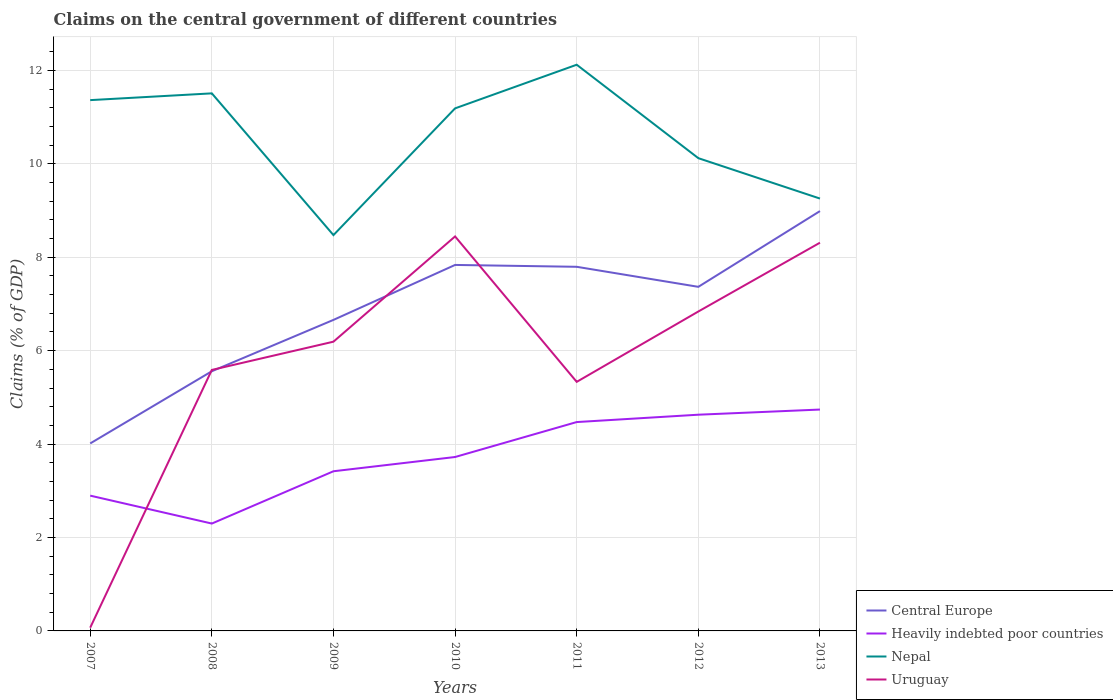Across all years, what is the maximum percentage of GDP claimed on the central government in Uruguay?
Give a very brief answer. 0.07. In which year was the percentage of GDP claimed on the central government in Uruguay maximum?
Offer a very short reply. 2007. What is the total percentage of GDP claimed on the central government in Heavily indebted poor countries in the graph?
Provide a succinct answer. -0.11. What is the difference between the highest and the second highest percentage of GDP claimed on the central government in Heavily indebted poor countries?
Your response must be concise. 2.44. What is the difference between the highest and the lowest percentage of GDP claimed on the central government in Uruguay?
Give a very brief answer. 4. How many years are there in the graph?
Ensure brevity in your answer.  7. Does the graph contain grids?
Keep it short and to the point. Yes. Where does the legend appear in the graph?
Keep it short and to the point. Bottom right. How many legend labels are there?
Keep it short and to the point. 4. What is the title of the graph?
Your response must be concise. Claims on the central government of different countries. What is the label or title of the Y-axis?
Provide a succinct answer. Claims (% of GDP). What is the Claims (% of GDP) of Central Europe in 2007?
Your answer should be very brief. 4.01. What is the Claims (% of GDP) in Heavily indebted poor countries in 2007?
Offer a terse response. 2.9. What is the Claims (% of GDP) of Nepal in 2007?
Your answer should be compact. 11.36. What is the Claims (% of GDP) of Uruguay in 2007?
Provide a succinct answer. 0.07. What is the Claims (% of GDP) of Central Europe in 2008?
Make the answer very short. 5.56. What is the Claims (% of GDP) of Heavily indebted poor countries in 2008?
Provide a succinct answer. 2.3. What is the Claims (% of GDP) of Nepal in 2008?
Ensure brevity in your answer.  11.51. What is the Claims (% of GDP) of Uruguay in 2008?
Keep it short and to the point. 5.59. What is the Claims (% of GDP) in Central Europe in 2009?
Your response must be concise. 6.66. What is the Claims (% of GDP) in Heavily indebted poor countries in 2009?
Keep it short and to the point. 3.42. What is the Claims (% of GDP) of Nepal in 2009?
Your answer should be very brief. 8.47. What is the Claims (% of GDP) of Uruguay in 2009?
Give a very brief answer. 6.19. What is the Claims (% of GDP) in Central Europe in 2010?
Your answer should be very brief. 7.84. What is the Claims (% of GDP) of Heavily indebted poor countries in 2010?
Offer a terse response. 3.72. What is the Claims (% of GDP) of Nepal in 2010?
Your answer should be compact. 11.19. What is the Claims (% of GDP) in Uruguay in 2010?
Make the answer very short. 8.45. What is the Claims (% of GDP) in Central Europe in 2011?
Give a very brief answer. 7.8. What is the Claims (% of GDP) of Heavily indebted poor countries in 2011?
Your response must be concise. 4.47. What is the Claims (% of GDP) of Nepal in 2011?
Provide a short and direct response. 12.12. What is the Claims (% of GDP) in Uruguay in 2011?
Offer a terse response. 5.33. What is the Claims (% of GDP) in Central Europe in 2012?
Your answer should be compact. 7.37. What is the Claims (% of GDP) of Heavily indebted poor countries in 2012?
Make the answer very short. 4.63. What is the Claims (% of GDP) of Nepal in 2012?
Provide a short and direct response. 10.12. What is the Claims (% of GDP) of Uruguay in 2012?
Your response must be concise. 6.84. What is the Claims (% of GDP) in Central Europe in 2013?
Offer a terse response. 8.99. What is the Claims (% of GDP) of Heavily indebted poor countries in 2013?
Your response must be concise. 4.74. What is the Claims (% of GDP) in Nepal in 2013?
Your answer should be compact. 9.26. What is the Claims (% of GDP) in Uruguay in 2013?
Make the answer very short. 8.31. Across all years, what is the maximum Claims (% of GDP) of Central Europe?
Ensure brevity in your answer.  8.99. Across all years, what is the maximum Claims (% of GDP) in Heavily indebted poor countries?
Offer a terse response. 4.74. Across all years, what is the maximum Claims (% of GDP) in Nepal?
Your answer should be very brief. 12.12. Across all years, what is the maximum Claims (% of GDP) of Uruguay?
Your answer should be very brief. 8.45. Across all years, what is the minimum Claims (% of GDP) of Central Europe?
Provide a succinct answer. 4.01. Across all years, what is the minimum Claims (% of GDP) of Heavily indebted poor countries?
Offer a very short reply. 2.3. Across all years, what is the minimum Claims (% of GDP) of Nepal?
Your answer should be compact. 8.47. Across all years, what is the minimum Claims (% of GDP) in Uruguay?
Your answer should be compact. 0.07. What is the total Claims (% of GDP) of Central Europe in the graph?
Your answer should be compact. 48.22. What is the total Claims (% of GDP) of Heavily indebted poor countries in the graph?
Make the answer very short. 26.18. What is the total Claims (% of GDP) of Nepal in the graph?
Make the answer very short. 74.04. What is the total Claims (% of GDP) of Uruguay in the graph?
Provide a succinct answer. 40.78. What is the difference between the Claims (% of GDP) of Central Europe in 2007 and that in 2008?
Keep it short and to the point. -1.55. What is the difference between the Claims (% of GDP) of Heavily indebted poor countries in 2007 and that in 2008?
Your response must be concise. 0.6. What is the difference between the Claims (% of GDP) in Nepal in 2007 and that in 2008?
Offer a very short reply. -0.14. What is the difference between the Claims (% of GDP) in Uruguay in 2007 and that in 2008?
Provide a short and direct response. -5.52. What is the difference between the Claims (% of GDP) of Central Europe in 2007 and that in 2009?
Provide a short and direct response. -2.65. What is the difference between the Claims (% of GDP) in Heavily indebted poor countries in 2007 and that in 2009?
Make the answer very short. -0.52. What is the difference between the Claims (% of GDP) in Nepal in 2007 and that in 2009?
Provide a succinct answer. 2.89. What is the difference between the Claims (% of GDP) of Uruguay in 2007 and that in 2009?
Offer a very short reply. -6.12. What is the difference between the Claims (% of GDP) in Central Europe in 2007 and that in 2010?
Offer a terse response. -3.82. What is the difference between the Claims (% of GDP) in Heavily indebted poor countries in 2007 and that in 2010?
Offer a very short reply. -0.83. What is the difference between the Claims (% of GDP) in Nepal in 2007 and that in 2010?
Provide a succinct answer. 0.18. What is the difference between the Claims (% of GDP) in Uruguay in 2007 and that in 2010?
Your response must be concise. -8.38. What is the difference between the Claims (% of GDP) of Central Europe in 2007 and that in 2011?
Make the answer very short. -3.78. What is the difference between the Claims (% of GDP) in Heavily indebted poor countries in 2007 and that in 2011?
Make the answer very short. -1.58. What is the difference between the Claims (% of GDP) in Nepal in 2007 and that in 2011?
Ensure brevity in your answer.  -0.76. What is the difference between the Claims (% of GDP) in Uruguay in 2007 and that in 2011?
Ensure brevity in your answer.  -5.26. What is the difference between the Claims (% of GDP) of Central Europe in 2007 and that in 2012?
Offer a very short reply. -3.35. What is the difference between the Claims (% of GDP) of Heavily indebted poor countries in 2007 and that in 2012?
Provide a short and direct response. -1.73. What is the difference between the Claims (% of GDP) of Nepal in 2007 and that in 2012?
Offer a very short reply. 1.24. What is the difference between the Claims (% of GDP) in Uruguay in 2007 and that in 2012?
Make the answer very short. -6.77. What is the difference between the Claims (% of GDP) in Central Europe in 2007 and that in 2013?
Keep it short and to the point. -4.97. What is the difference between the Claims (% of GDP) of Heavily indebted poor countries in 2007 and that in 2013?
Ensure brevity in your answer.  -1.84. What is the difference between the Claims (% of GDP) in Nepal in 2007 and that in 2013?
Offer a terse response. 2.11. What is the difference between the Claims (% of GDP) of Uruguay in 2007 and that in 2013?
Your response must be concise. -8.24. What is the difference between the Claims (% of GDP) of Central Europe in 2008 and that in 2009?
Offer a very short reply. -1.1. What is the difference between the Claims (% of GDP) in Heavily indebted poor countries in 2008 and that in 2009?
Give a very brief answer. -1.12. What is the difference between the Claims (% of GDP) in Nepal in 2008 and that in 2009?
Your response must be concise. 3.03. What is the difference between the Claims (% of GDP) in Uruguay in 2008 and that in 2009?
Offer a terse response. -0.6. What is the difference between the Claims (% of GDP) in Central Europe in 2008 and that in 2010?
Provide a short and direct response. -2.28. What is the difference between the Claims (% of GDP) in Heavily indebted poor countries in 2008 and that in 2010?
Your answer should be very brief. -1.42. What is the difference between the Claims (% of GDP) of Nepal in 2008 and that in 2010?
Keep it short and to the point. 0.32. What is the difference between the Claims (% of GDP) in Uruguay in 2008 and that in 2010?
Keep it short and to the point. -2.86. What is the difference between the Claims (% of GDP) of Central Europe in 2008 and that in 2011?
Keep it short and to the point. -2.24. What is the difference between the Claims (% of GDP) in Heavily indebted poor countries in 2008 and that in 2011?
Your response must be concise. -2.17. What is the difference between the Claims (% of GDP) in Nepal in 2008 and that in 2011?
Your answer should be very brief. -0.61. What is the difference between the Claims (% of GDP) in Uruguay in 2008 and that in 2011?
Your answer should be very brief. 0.26. What is the difference between the Claims (% of GDP) in Central Europe in 2008 and that in 2012?
Offer a terse response. -1.81. What is the difference between the Claims (% of GDP) of Heavily indebted poor countries in 2008 and that in 2012?
Ensure brevity in your answer.  -2.33. What is the difference between the Claims (% of GDP) of Nepal in 2008 and that in 2012?
Make the answer very short. 1.39. What is the difference between the Claims (% of GDP) in Uruguay in 2008 and that in 2012?
Your response must be concise. -1.25. What is the difference between the Claims (% of GDP) in Central Europe in 2008 and that in 2013?
Offer a very short reply. -3.43. What is the difference between the Claims (% of GDP) of Heavily indebted poor countries in 2008 and that in 2013?
Provide a short and direct response. -2.44. What is the difference between the Claims (% of GDP) of Nepal in 2008 and that in 2013?
Provide a short and direct response. 2.25. What is the difference between the Claims (% of GDP) of Uruguay in 2008 and that in 2013?
Make the answer very short. -2.72. What is the difference between the Claims (% of GDP) in Central Europe in 2009 and that in 2010?
Give a very brief answer. -1.18. What is the difference between the Claims (% of GDP) of Heavily indebted poor countries in 2009 and that in 2010?
Offer a terse response. -0.31. What is the difference between the Claims (% of GDP) in Nepal in 2009 and that in 2010?
Offer a very short reply. -2.71. What is the difference between the Claims (% of GDP) in Uruguay in 2009 and that in 2010?
Provide a short and direct response. -2.25. What is the difference between the Claims (% of GDP) of Central Europe in 2009 and that in 2011?
Your answer should be very brief. -1.14. What is the difference between the Claims (% of GDP) in Heavily indebted poor countries in 2009 and that in 2011?
Your response must be concise. -1.05. What is the difference between the Claims (% of GDP) in Nepal in 2009 and that in 2011?
Your response must be concise. -3.65. What is the difference between the Claims (% of GDP) in Uruguay in 2009 and that in 2011?
Keep it short and to the point. 0.86. What is the difference between the Claims (% of GDP) of Central Europe in 2009 and that in 2012?
Your answer should be very brief. -0.71. What is the difference between the Claims (% of GDP) in Heavily indebted poor countries in 2009 and that in 2012?
Ensure brevity in your answer.  -1.21. What is the difference between the Claims (% of GDP) in Nepal in 2009 and that in 2012?
Keep it short and to the point. -1.65. What is the difference between the Claims (% of GDP) in Uruguay in 2009 and that in 2012?
Your answer should be compact. -0.65. What is the difference between the Claims (% of GDP) in Central Europe in 2009 and that in 2013?
Your response must be concise. -2.33. What is the difference between the Claims (% of GDP) of Heavily indebted poor countries in 2009 and that in 2013?
Keep it short and to the point. -1.32. What is the difference between the Claims (% of GDP) in Nepal in 2009 and that in 2013?
Offer a very short reply. -0.78. What is the difference between the Claims (% of GDP) in Uruguay in 2009 and that in 2013?
Your answer should be very brief. -2.12. What is the difference between the Claims (% of GDP) in Central Europe in 2010 and that in 2011?
Give a very brief answer. 0.04. What is the difference between the Claims (% of GDP) of Heavily indebted poor countries in 2010 and that in 2011?
Provide a short and direct response. -0.75. What is the difference between the Claims (% of GDP) of Nepal in 2010 and that in 2011?
Give a very brief answer. -0.93. What is the difference between the Claims (% of GDP) in Uruguay in 2010 and that in 2011?
Your response must be concise. 3.11. What is the difference between the Claims (% of GDP) in Central Europe in 2010 and that in 2012?
Offer a terse response. 0.47. What is the difference between the Claims (% of GDP) of Heavily indebted poor countries in 2010 and that in 2012?
Offer a terse response. -0.91. What is the difference between the Claims (% of GDP) in Nepal in 2010 and that in 2012?
Provide a short and direct response. 1.07. What is the difference between the Claims (% of GDP) in Uruguay in 2010 and that in 2012?
Your answer should be very brief. 1.61. What is the difference between the Claims (% of GDP) in Central Europe in 2010 and that in 2013?
Your answer should be compact. -1.15. What is the difference between the Claims (% of GDP) in Heavily indebted poor countries in 2010 and that in 2013?
Ensure brevity in your answer.  -1.02. What is the difference between the Claims (% of GDP) of Nepal in 2010 and that in 2013?
Ensure brevity in your answer.  1.93. What is the difference between the Claims (% of GDP) of Uruguay in 2010 and that in 2013?
Keep it short and to the point. 0.13. What is the difference between the Claims (% of GDP) of Central Europe in 2011 and that in 2012?
Ensure brevity in your answer.  0.43. What is the difference between the Claims (% of GDP) of Heavily indebted poor countries in 2011 and that in 2012?
Provide a succinct answer. -0.16. What is the difference between the Claims (% of GDP) of Nepal in 2011 and that in 2012?
Keep it short and to the point. 2. What is the difference between the Claims (% of GDP) in Uruguay in 2011 and that in 2012?
Your answer should be very brief. -1.51. What is the difference between the Claims (% of GDP) of Central Europe in 2011 and that in 2013?
Offer a very short reply. -1.19. What is the difference between the Claims (% of GDP) of Heavily indebted poor countries in 2011 and that in 2013?
Give a very brief answer. -0.27. What is the difference between the Claims (% of GDP) in Nepal in 2011 and that in 2013?
Offer a very short reply. 2.87. What is the difference between the Claims (% of GDP) of Uruguay in 2011 and that in 2013?
Keep it short and to the point. -2.98. What is the difference between the Claims (% of GDP) in Central Europe in 2012 and that in 2013?
Make the answer very short. -1.62. What is the difference between the Claims (% of GDP) in Heavily indebted poor countries in 2012 and that in 2013?
Ensure brevity in your answer.  -0.11. What is the difference between the Claims (% of GDP) in Nepal in 2012 and that in 2013?
Your answer should be compact. 0.86. What is the difference between the Claims (% of GDP) of Uruguay in 2012 and that in 2013?
Your answer should be compact. -1.47. What is the difference between the Claims (% of GDP) of Central Europe in 2007 and the Claims (% of GDP) of Heavily indebted poor countries in 2008?
Your answer should be very brief. 1.72. What is the difference between the Claims (% of GDP) of Central Europe in 2007 and the Claims (% of GDP) of Nepal in 2008?
Provide a succinct answer. -7.5. What is the difference between the Claims (% of GDP) in Central Europe in 2007 and the Claims (% of GDP) in Uruguay in 2008?
Offer a very short reply. -1.57. What is the difference between the Claims (% of GDP) in Heavily indebted poor countries in 2007 and the Claims (% of GDP) in Nepal in 2008?
Offer a very short reply. -8.61. What is the difference between the Claims (% of GDP) of Heavily indebted poor countries in 2007 and the Claims (% of GDP) of Uruguay in 2008?
Your answer should be compact. -2.69. What is the difference between the Claims (% of GDP) in Nepal in 2007 and the Claims (% of GDP) in Uruguay in 2008?
Make the answer very short. 5.78. What is the difference between the Claims (% of GDP) in Central Europe in 2007 and the Claims (% of GDP) in Heavily indebted poor countries in 2009?
Keep it short and to the point. 0.6. What is the difference between the Claims (% of GDP) in Central Europe in 2007 and the Claims (% of GDP) in Nepal in 2009?
Make the answer very short. -4.46. What is the difference between the Claims (% of GDP) in Central Europe in 2007 and the Claims (% of GDP) in Uruguay in 2009?
Your answer should be compact. -2.18. What is the difference between the Claims (% of GDP) of Heavily indebted poor countries in 2007 and the Claims (% of GDP) of Nepal in 2009?
Your answer should be compact. -5.58. What is the difference between the Claims (% of GDP) of Heavily indebted poor countries in 2007 and the Claims (% of GDP) of Uruguay in 2009?
Your answer should be compact. -3.3. What is the difference between the Claims (% of GDP) in Nepal in 2007 and the Claims (% of GDP) in Uruguay in 2009?
Give a very brief answer. 5.17. What is the difference between the Claims (% of GDP) of Central Europe in 2007 and the Claims (% of GDP) of Heavily indebted poor countries in 2010?
Your answer should be compact. 0.29. What is the difference between the Claims (% of GDP) of Central Europe in 2007 and the Claims (% of GDP) of Nepal in 2010?
Provide a succinct answer. -7.17. What is the difference between the Claims (% of GDP) of Central Europe in 2007 and the Claims (% of GDP) of Uruguay in 2010?
Provide a short and direct response. -4.43. What is the difference between the Claims (% of GDP) of Heavily indebted poor countries in 2007 and the Claims (% of GDP) of Nepal in 2010?
Make the answer very short. -8.29. What is the difference between the Claims (% of GDP) in Heavily indebted poor countries in 2007 and the Claims (% of GDP) in Uruguay in 2010?
Your response must be concise. -5.55. What is the difference between the Claims (% of GDP) in Nepal in 2007 and the Claims (% of GDP) in Uruguay in 2010?
Your answer should be compact. 2.92. What is the difference between the Claims (% of GDP) of Central Europe in 2007 and the Claims (% of GDP) of Heavily indebted poor countries in 2011?
Make the answer very short. -0.46. What is the difference between the Claims (% of GDP) in Central Europe in 2007 and the Claims (% of GDP) in Nepal in 2011?
Keep it short and to the point. -8.11. What is the difference between the Claims (% of GDP) in Central Europe in 2007 and the Claims (% of GDP) in Uruguay in 2011?
Provide a short and direct response. -1.32. What is the difference between the Claims (% of GDP) of Heavily indebted poor countries in 2007 and the Claims (% of GDP) of Nepal in 2011?
Offer a terse response. -9.23. What is the difference between the Claims (% of GDP) of Heavily indebted poor countries in 2007 and the Claims (% of GDP) of Uruguay in 2011?
Give a very brief answer. -2.44. What is the difference between the Claims (% of GDP) in Nepal in 2007 and the Claims (% of GDP) in Uruguay in 2011?
Make the answer very short. 6.03. What is the difference between the Claims (% of GDP) of Central Europe in 2007 and the Claims (% of GDP) of Heavily indebted poor countries in 2012?
Your answer should be compact. -0.62. What is the difference between the Claims (% of GDP) in Central Europe in 2007 and the Claims (% of GDP) in Nepal in 2012?
Offer a very short reply. -6.11. What is the difference between the Claims (% of GDP) in Central Europe in 2007 and the Claims (% of GDP) in Uruguay in 2012?
Offer a very short reply. -2.83. What is the difference between the Claims (% of GDP) in Heavily indebted poor countries in 2007 and the Claims (% of GDP) in Nepal in 2012?
Ensure brevity in your answer.  -7.22. What is the difference between the Claims (% of GDP) of Heavily indebted poor countries in 2007 and the Claims (% of GDP) of Uruguay in 2012?
Give a very brief answer. -3.94. What is the difference between the Claims (% of GDP) of Nepal in 2007 and the Claims (% of GDP) of Uruguay in 2012?
Give a very brief answer. 4.53. What is the difference between the Claims (% of GDP) in Central Europe in 2007 and the Claims (% of GDP) in Heavily indebted poor countries in 2013?
Offer a terse response. -0.73. What is the difference between the Claims (% of GDP) of Central Europe in 2007 and the Claims (% of GDP) of Nepal in 2013?
Give a very brief answer. -5.24. What is the difference between the Claims (% of GDP) in Central Europe in 2007 and the Claims (% of GDP) in Uruguay in 2013?
Provide a short and direct response. -4.3. What is the difference between the Claims (% of GDP) of Heavily indebted poor countries in 2007 and the Claims (% of GDP) of Nepal in 2013?
Ensure brevity in your answer.  -6.36. What is the difference between the Claims (% of GDP) in Heavily indebted poor countries in 2007 and the Claims (% of GDP) in Uruguay in 2013?
Provide a short and direct response. -5.42. What is the difference between the Claims (% of GDP) of Nepal in 2007 and the Claims (% of GDP) of Uruguay in 2013?
Provide a succinct answer. 3.05. What is the difference between the Claims (% of GDP) of Central Europe in 2008 and the Claims (% of GDP) of Heavily indebted poor countries in 2009?
Provide a succinct answer. 2.14. What is the difference between the Claims (% of GDP) of Central Europe in 2008 and the Claims (% of GDP) of Nepal in 2009?
Offer a terse response. -2.91. What is the difference between the Claims (% of GDP) of Central Europe in 2008 and the Claims (% of GDP) of Uruguay in 2009?
Provide a short and direct response. -0.63. What is the difference between the Claims (% of GDP) of Heavily indebted poor countries in 2008 and the Claims (% of GDP) of Nepal in 2009?
Your answer should be very brief. -6.18. What is the difference between the Claims (% of GDP) of Heavily indebted poor countries in 2008 and the Claims (% of GDP) of Uruguay in 2009?
Provide a short and direct response. -3.89. What is the difference between the Claims (% of GDP) in Nepal in 2008 and the Claims (% of GDP) in Uruguay in 2009?
Your answer should be compact. 5.32. What is the difference between the Claims (% of GDP) in Central Europe in 2008 and the Claims (% of GDP) in Heavily indebted poor countries in 2010?
Give a very brief answer. 1.84. What is the difference between the Claims (% of GDP) of Central Europe in 2008 and the Claims (% of GDP) of Nepal in 2010?
Offer a very short reply. -5.63. What is the difference between the Claims (% of GDP) in Central Europe in 2008 and the Claims (% of GDP) in Uruguay in 2010?
Ensure brevity in your answer.  -2.89. What is the difference between the Claims (% of GDP) of Heavily indebted poor countries in 2008 and the Claims (% of GDP) of Nepal in 2010?
Provide a succinct answer. -8.89. What is the difference between the Claims (% of GDP) in Heavily indebted poor countries in 2008 and the Claims (% of GDP) in Uruguay in 2010?
Make the answer very short. -6.15. What is the difference between the Claims (% of GDP) of Nepal in 2008 and the Claims (% of GDP) of Uruguay in 2010?
Your answer should be compact. 3.06. What is the difference between the Claims (% of GDP) of Central Europe in 2008 and the Claims (% of GDP) of Heavily indebted poor countries in 2011?
Offer a terse response. 1.09. What is the difference between the Claims (% of GDP) in Central Europe in 2008 and the Claims (% of GDP) in Nepal in 2011?
Keep it short and to the point. -6.56. What is the difference between the Claims (% of GDP) of Central Europe in 2008 and the Claims (% of GDP) of Uruguay in 2011?
Keep it short and to the point. 0.23. What is the difference between the Claims (% of GDP) of Heavily indebted poor countries in 2008 and the Claims (% of GDP) of Nepal in 2011?
Your response must be concise. -9.82. What is the difference between the Claims (% of GDP) of Heavily indebted poor countries in 2008 and the Claims (% of GDP) of Uruguay in 2011?
Provide a succinct answer. -3.03. What is the difference between the Claims (% of GDP) in Nepal in 2008 and the Claims (% of GDP) in Uruguay in 2011?
Your answer should be very brief. 6.18. What is the difference between the Claims (% of GDP) of Central Europe in 2008 and the Claims (% of GDP) of Heavily indebted poor countries in 2012?
Make the answer very short. 0.93. What is the difference between the Claims (% of GDP) in Central Europe in 2008 and the Claims (% of GDP) in Nepal in 2012?
Your answer should be very brief. -4.56. What is the difference between the Claims (% of GDP) of Central Europe in 2008 and the Claims (% of GDP) of Uruguay in 2012?
Make the answer very short. -1.28. What is the difference between the Claims (% of GDP) in Heavily indebted poor countries in 2008 and the Claims (% of GDP) in Nepal in 2012?
Your answer should be compact. -7.82. What is the difference between the Claims (% of GDP) of Heavily indebted poor countries in 2008 and the Claims (% of GDP) of Uruguay in 2012?
Offer a terse response. -4.54. What is the difference between the Claims (% of GDP) of Nepal in 2008 and the Claims (% of GDP) of Uruguay in 2012?
Your answer should be compact. 4.67. What is the difference between the Claims (% of GDP) in Central Europe in 2008 and the Claims (% of GDP) in Heavily indebted poor countries in 2013?
Your answer should be compact. 0.82. What is the difference between the Claims (% of GDP) of Central Europe in 2008 and the Claims (% of GDP) of Nepal in 2013?
Give a very brief answer. -3.7. What is the difference between the Claims (% of GDP) in Central Europe in 2008 and the Claims (% of GDP) in Uruguay in 2013?
Your answer should be compact. -2.75. What is the difference between the Claims (% of GDP) of Heavily indebted poor countries in 2008 and the Claims (% of GDP) of Nepal in 2013?
Offer a terse response. -6.96. What is the difference between the Claims (% of GDP) of Heavily indebted poor countries in 2008 and the Claims (% of GDP) of Uruguay in 2013?
Ensure brevity in your answer.  -6.01. What is the difference between the Claims (% of GDP) in Nepal in 2008 and the Claims (% of GDP) in Uruguay in 2013?
Offer a very short reply. 3.2. What is the difference between the Claims (% of GDP) of Central Europe in 2009 and the Claims (% of GDP) of Heavily indebted poor countries in 2010?
Make the answer very short. 2.94. What is the difference between the Claims (% of GDP) in Central Europe in 2009 and the Claims (% of GDP) in Nepal in 2010?
Keep it short and to the point. -4.53. What is the difference between the Claims (% of GDP) of Central Europe in 2009 and the Claims (% of GDP) of Uruguay in 2010?
Your answer should be very brief. -1.79. What is the difference between the Claims (% of GDP) in Heavily indebted poor countries in 2009 and the Claims (% of GDP) in Nepal in 2010?
Keep it short and to the point. -7.77. What is the difference between the Claims (% of GDP) of Heavily indebted poor countries in 2009 and the Claims (% of GDP) of Uruguay in 2010?
Offer a very short reply. -5.03. What is the difference between the Claims (% of GDP) of Nepal in 2009 and the Claims (% of GDP) of Uruguay in 2010?
Ensure brevity in your answer.  0.03. What is the difference between the Claims (% of GDP) in Central Europe in 2009 and the Claims (% of GDP) in Heavily indebted poor countries in 2011?
Keep it short and to the point. 2.19. What is the difference between the Claims (% of GDP) in Central Europe in 2009 and the Claims (% of GDP) in Nepal in 2011?
Give a very brief answer. -5.46. What is the difference between the Claims (% of GDP) of Central Europe in 2009 and the Claims (% of GDP) of Uruguay in 2011?
Give a very brief answer. 1.33. What is the difference between the Claims (% of GDP) of Heavily indebted poor countries in 2009 and the Claims (% of GDP) of Nepal in 2011?
Provide a succinct answer. -8.7. What is the difference between the Claims (% of GDP) in Heavily indebted poor countries in 2009 and the Claims (% of GDP) in Uruguay in 2011?
Make the answer very short. -1.91. What is the difference between the Claims (% of GDP) of Nepal in 2009 and the Claims (% of GDP) of Uruguay in 2011?
Offer a very short reply. 3.14. What is the difference between the Claims (% of GDP) of Central Europe in 2009 and the Claims (% of GDP) of Heavily indebted poor countries in 2012?
Provide a short and direct response. 2.03. What is the difference between the Claims (% of GDP) in Central Europe in 2009 and the Claims (% of GDP) in Nepal in 2012?
Keep it short and to the point. -3.46. What is the difference between the Claims (% of GDP) in Central Europe in 2009 and the Claims (% of GDP) in Uruguay in 2012?
Provide a short and direct response. -0.18. What is the difference between the Claims (% of GDP) of Heavily indebted poor countries in 2009 and the Claims (% of GDP) of Nepal in 2012?
Give a very brief answer. -6.7. What is the difference between the Claims (% of GDP) of Heavily indebted poor countries in 2009 and the Claims (% of GDP) of Uruguay in 2012?
Offer a very short reply. -3.42. What is the difference between the Claims (% of GDP) of Nepal in 2009 and the Claims (% of GDP) of Uruguay in 2012?
Your response must be concise. 1.64. What is the difference between the Claims (% of GDP) of Central Europe in 2009 and the Claims (% of GDP) of Heavily indebted poor countries in 2013?
Provide a short and direct response. 1.92. What is the difference between the Claims (% of GDP) of Central Europe in 2009 and the Claims (% of GDP) of Nepal in 2013?
Keep it short and to the point. -2.6. What is the difference between the Claims (% of GDP) of Central Europe in 2009 and the Claims (% of GDP) of Uruguay in 2013?
Make the answer very short. -1.65. What is the difference between the Claims (% of GDP) of Heavily indebted poor countries in 2009 and the Claims (% of GDP) of Nepal in 2013?
Provide a short and direct response. -5.84. What is the difference between the Claims (% of GDP) in Heavily indebted poor countries in 2009 and the Claims (% of GDP) in Uruguay in 2013?
Your response must be concise. -4.89. What is the difference between the Claims (% of GDP) of Nepal in 2009 and the Claims (% of GDP) of Uruguay in 2013?
Ensure brevity in your answer.  0.16. What is the difference between the Claims (% of GDP) in Central Europe in 2010 and the Claims (% of GDP) in Heavily indebted poor countries in 2011?
Your response must be concise. 3.36. What is the difference between the Claims (% of GDP) of Central Europe in 2010 and the Claims (% of GDP) of Nepal in 2011?
Offer a terse response. -4.29. What is the difference between the Claims (% of GDP) in Central Europe in 2010 and the Claims (% of GDP) in Uruguay in 2011?
Make the answer very short. 2.5. What is the difference between the Claims (% of GDP) in Heavily indebted poor countries in 2010 and the Claims (% of GDP) in Nepal in 2011?
Make the answer very short. -8.4. What is the difference between the Claims (% of GDP) of Heavily indebted poor countries in 2010 and the Claims (% of GDP) of Uruguay in 2011?
Provide a short and direct response. -1.61. What is the difference between the Claims (% of GDP) of Nepal in 2010 and the Claims (% of GDP) of Uruguay in 2011?
Your answer should be very brief. 5.86. What is the difference between the Claims (% of GDP) in Central Europe in 2010 and the Claims (% of GDP) in Heavily indebted poor countries in 2012?
Your answer should be compact. 3.21. What is the difference between the Claims (% of GDP) of Central Europe in 2010 and the Claims (% of GDP) of Nepal in 2012?
Your answer should be very brief. -2.29. What is the difference between the Claims (% of GDP) of Heavily indebted poor countries in 2010 and the Claims (% of GDP) of Nepal in 2012?
Your answer should be very brief. -6.4. What is the difference between the Claims (% of GDP) of Heavily indebted poor countries in 2010 and the Claims (% of GDP) of Uruguay in 2012?
Offer a very short reply. -3.12. What is the difference between the Claims (% of GDP) of Nepal in 2010 and the Claims (% of GDP) of Uruguay in 2012?
Give a very brief answer. 4.35. What is the difference between the Claims (% of GDP) in Central Europe in 2010 and the Claims (% of GDP) in Heavily indebted poor countries in 2013?
Give a very brief answer. 3.1. What is the difference between the Claims (% of GDP) of Central Europe in 2010 and the Claims (% of GDP) of Nepal in 2013?
Offer a terse response. -1.42. What is the difference between the Claims (% of GDP) in Central Europe in 2010 and the Claims (% of GDP) in Uruguay in 2013?
Give a very brief answer. -0.48. What is the difference between the Claims (% of GDP) in Heavily indebted poor countries in 2010 and the Claims (% of GDP) in Nepal in 2013?
Offer a very short reply. -5.53. What is the difference between the Claims (% of GDP) in Heavily indebted poor countries in 2010 and the Claims (% of GDP) in Uruguay in 2013?
Your answer should be compact. -4.59. What is the difference between the Claims (% of GDP) in Nepal in 2010 and the Claims (% of GDP) in Uruguay in 2013?
Offer a terse response. 2.88. What is the difference between the Claims (% of GDP) in Central Europe in 2011 and the Claims (% of GDP) in Heavily indebted poor countries in 2012?
Provide a succinct answer. 3.17. What is the difference between the Claims (% of GDP) in Central Europe in 2011 and the Claims (% of GDP) in Nepal in 2012?
Make the answer very short. -2.33. What is the difference between the Claims (% of GDP) in Central Europe in 2011 and the Claims (% of GDP) in Uruguay in 2012?
Give a very brief answer. 0.96. What is the difference between the Claims (% of GDP) in Heavily indebted poor countries in 2011 and the Claims (% of GDP) in Nepal in 2012?
Ensure brevity in your answer.  -5.65. What is the difference between the Claims (% of GDP) in Heavily indebted poor countries in 2011 and the Claims (% of GDP) in Uruguay in 2012?
Your response must be concise. -2.37. What is the difference between the Claims (% of GDP) of Nepal in 2011 and the Claims (% of GDP) of Uruguay in 2012?
Keep it short and to the point. 5.28. What is the difference between the Claims (% of GDP) of Central Europe in 2011 and the Claims (% of GDP) of Heavily indebted poor countries in 2013?
Offer a very short reply. 3.06. What is the difference between the Claims (% of GDP) of Central Europe in 2011 and the Claims (% of GDP) of Nepal in 2013?
Provide a succinct answer. -1.46. What is the difference between the Claims (% of GDP) in Central Europe in 2011 and the Claims (% of GDP) in Uruguay in 2013?
Your answer should be compact. -0.52. What is the difference between the Claims (% of GDP) of Heavily indebted poor countries in 2011 and the Claims (% of GDP) of Nepal in 2013?
Make the answer very short. -4.79. What is the difference between the Claims (% of GDP) in Heavily indebted poor countries in 2011 and the Claims (% of GDP) in Uruguay in 2013?
Ensure brevity in your answer.  -3.84. What is the difference between the Claims (% of GDP) in Nepal in 2011 and the Claims (% of GDP) in Uruguay in 2013?
Your answer should be very brief. 3.81. What is the difference between the Claims (% of GDP) of Central Europe in 2012 and the Claims (% of GDP) of Heavily indebted poor countries in 2013?
Keep it short and to the point. 2.63. What is the difference between the Claims (% of GDP) in Central Europe in 2012 and the Claims (% of GDP) in Nepal in 2013?
Keep it short and to the point. -1.89. What is the difference between the Claims (% of GDP) of Central Europe in 2012 and the Claims (% of GDP) of Uruguay in 2013?
Offer a terse response. -0.95. What is the difference between the Claims (% of GDP) in Heavily indebted poor countries in 2012 and the Claims (% of GDP) in Nepal in 2013?
Provide a succinct answer. -4.63. What is the difference between the Claims (% of GDP) in Heavily indebted poor countries in 2012 and the Claims (% of GDP) in Uruguay in 2013?
Provide a succinct answer. -3.68. What is the difference between the Claims (% of GDP) of Nepal in 2012 and the Claims (% of GDP) of Uruguay in 2013?
Your answer should be very brief. 1.81. What is the average Claims (% of GDP) in Central Europe per year?
Your response must be concise. 6.89. What is the average Claims (% of GDP) in Heavily indebted poor countries per year?
Provide a short and direct response. 3.74. What is the average Claims (% of GDP) in Nepal per year?
Ensure brevity in your answer.  10.58. What is the average Claims (% of GDP) of Uruguay per year?
Provide a succinct answer. 5.83. In the year 2007, what is the difference between the Claims (% of GDP) of Central Europe and Claims (% of GDP) of Heavily indebted poor countries?
Ensure brevity in your answer.  1.12. In the year 2007, what is the difference between the Claims (% of GDP) in Central Europe and Claims (% of GDP) in Nepal?
Your answer should be compact. -7.35. In the year 2007, what is the difference between the Claims (% of GDP) in Central Europe and Claims (% of GDP) in Uruguay?
Keep it short and to the point. 3.94. In the year 2007, what is the difference between the Claims (% of GDP) of Heavily indebted poor countries and Claims (% of GDP) of Nepal?
Your response must be concise. -8.47. In the year 2007, what is the difference between the Claims (% of GDP) in Heavily indebted poor countries and Claims (% of GDP) in Uruguay?
Your response must be concise. 2.83. In the year 2007, what is the difference between the Claims (% of GDP) of Nepal and Claims (% of GDP) of Uruguay?
Provide a succinct answer. 11.29. In the year 2008, what is the difference between the Claims (% of GDP) of Central Europe and Claims (% of GDP) of Heavily indebted poor countries?
Keep it short and to the point. 3.26. In the year 2008, what is the difference between the Claims (% of GDP) of Central Europe and Claims (% of GDP) of Nepal?
Provide a succinct answer. -5.95. In the year 2008, what is the difference between the Claims (% of GDP) of Central Europe and Claims (% of GDP) of Uruguay?
Offer a very short reply. -0.03. In the year 2008, what is the difference between the Claims (% of GDP) of Heavily indebted poor countries and Claims (% of GDP) of Nepal?
Offer a terse response. -9.21. In the year 2008, what is the difference between the Claims (% of GDP) of Heavily indebted poor countries and Claims (% of GDP) of Uruguay?
Your response must be concise. -3.29. In the year 2008, what is the difference between the Claims (% of GDP) in Nepal and Claims (% of GDP) in Uruguay?
Ensure brevity in your answer.  5.92. In the year 2009, what is the difference between the Claims (% of GDP) in Central Europe and Claims (% of GDP) in Heavily indebted poor countries?
Your response must be concise. 3.24. In the year 2009, what is the difference between the Claims (% of GDP) in Central Europe and Claims (% of GDP) in Nepal?
Your answer should be compact. -1.82. In the year 2009, what is the difference between the Claims (% of GDP) of Central Europe and Claims (% of GDP) of Uruguay?
Offer a terse response. 0.47. In the year 2009, what is the difference between the Claims (% of GDP) in Heavily indebted poor countries and Claims (% of GDP) in Nepal?
Keep it short and to the point. -5.06. In the year 2009, what is the difference between the Claims (% of GDP) of Heavily indebted poor countries and Claims (% of GDP) of Uruguay?
Your response must be concise. -2.77. In the year 2009, what is the difference between the Claims (% of GDP) in Nepal and Claims (% of GDP) in Uruguay?
Your answer should be very brief. 2.28. In the year 2010, what is the difference between the Claims (% of GDP) of Central Europe and Claims (% of GDP) of Heavily indebted poor countries?
Give a very brief answer. 4.11. In the year 2010, what is the difference between the Claims (% of GDP) in Central Europe and Claims (% of GDP) in Nepal?
Keep it short and to the point. -3.35. In the year 2010, what is the difference between the Claims (% of GDP) in Central Europe and Claims (% of GDP) in Uruguay?
Provide a succinct answer. -0.61. In the year 2010, what is the difference between the Claims (% of GDP) in Heavily indebted poor countries and Claims (% of GDP) in Nepal?
Give a very brief answer. -7.46. In the year 2010, what is the difference between the Claims (% of GDP) in Heavily indebted poor countries and Claims (% of GDP) in Uruguay?
Offer a terse response. -4.72. In the year 2010, what is the difference between the Claims (% of GDP) of Nepal and Claims (% of GDP) of Uruguay?
Provide a short and direct response. 2.74. In the year 2011, what is the difference between the Claims (% of GDP) of Central Europe and Claims (% of GDP) of Heavily indebted poor countries?
Ensure brevity in your answer.  3.32. In the year 2011, what is the difference between the Claims (% of GDP) in Central Europe and Claims (% of GDP) in Nepal?
Provide a succinct answer. -4.33. In the year 2011, what is the difference between the Claims (% of GDP) of Central Europe and Claims (% of GDP) of Uruguay?
Make the answer very short. 2.46. In the year 2011, what is the difference between the Claims (% of GDP) in Heavily indebted poor countries and Claims (% of GDP) in Nepal?
Keep it short and to the point. -7.65. In the year 2011, what is the difference between the Claims (% of GDP) of Heavily indebted poor countries and Claims (% of GDP) of Uruguay?
Make the answer very short. -0.86. In the year 2011, what is the difference between the Claims (% of GDP) of Nepal and Claims (% of GDP) of Uruguay?
Ensure brevity in your answer.  6.79. In the year 2012, what is the difference between the Claims (% of GDP) of Central Europe and Claims (% of GDP) of Heavily indebted poor countries?
Your response must be concise. 2.74. In the year 2012, what is the difference between the Claims (% of GDP) of Central Europe and Claims (% of GDP) of Nepal?
Offer a terse response. -2.75. In the year 2012, what is the difference between the Claims (% of GDP) in Central Europe and Claims (% of GDP) in Uruguay?
Your answer should be compact. 0.53. In the year 2012, what is the difference between the Claims (% of GDP) in Heavily indebted poor countries and Claims (% of GDP) in Nepal?
Provide a short and direct response. -5.49. In the year 2012, what is the difference between the Claims (% of GDP) in Heavily indebted poor countries and Claims (% of GDP) in Uruguay?
Offer a terse response. -2.21. In the year 2012, what is the difference between the Claims (% of GDP) in Nepal and Claims (% of GDP) in Uruguay?
Provide a succinct answer. 3.28. In the year 2013, what is the difference between the Claims (% of GDP) of Central Europe and Claims (% of GDP) of Heavily indebted poor countries?
Ensure brevity in your answer.  4.25. In the year 2013, what is the difference between the Claims (% of GDP) of Central Europe and Claims (% of GDP) of Nepal?
Keep it short and to the point. -0.27. In the year 2013, what is the difference between the Claims (% of GDP) in Central Europe and Claims (% of GDP) in Uruguay?
Give a very brief answer. 0.68. In the year 2013, what is the difference between the Claims (% of GDP) of Heavily indebted poor countries and Claims (% of GDP) of Nepal?
Offer a very short reply. -4.52. In the year 2013, what is the difference between the Claims (% of GDP) of Heavily indebted poor countries and Claims (% of GDP) of Uruguay?
Give a very brief answer. -3.57. In the year 2013, what is the difference between the Claims (% of GDP) in Nepal and Claims (% of GDP) in Uruguay?
Your response must be concise. 0.94. What is the ratio of the Claims (% of GDP) in Central Europe in 2007 to that in 2008?
Your answer should be compact. 0.72. What is the ratio of the Claims (% of GDP) in Heavily indebted poor countries in 2007 to that in 2008?
Offer a terse response. 1.26. What is the ratio of the Claims (% of GDP) of Nepal in 2007 to that in 2008?
Make the answer very short. 0.99. What is the ratio of the Claims (% of GDP) of Uruguay in 2007 to that in 2008?
Offer a very short reply. 0.01. What is the ratio of the Claims (% of GDP) in Central Europe in 2007 to that in 2009?
Provide a succinct answer. 0.6. What is the ratio of the Claims (% of GDP) of Heavily indebted poor countries in 2007 to that in 2009?
Provide a short and direct response. 0.85. What is the ratio of the Claims (% of GDP) in Nepal in 2007 to that in 2009?
Your response must be concise. 1.34. What is the ratio of the Claims (% of GDP) in Uruguay in 2007 to that in 2009?
Ensure brevity in your answer.  0.01. What is the ratio of the Claims (% of GDP) in Central Europe in 2007 to that in 2010?
Provide a succinct answer. 0.51. What is the ratio of the Claims (% of GDP) in Heavily indebted poor countries in 2007 to that in 2010?
Offer a very short reply. 0.78. What is the ratio of the Claims (% of GDP) of Nepal in 2007 to that in 2010?
Provide a short and direct response. 1.02. What is the ratio of the Claims (% of GDP) in Uruguay in 2007 to that in 2010?
Offer a very short reply. 0.01. What is the ratio of the Claims (% of GDP) in Central Europe in 2007 to that in 2011?
Your answer should be compact. 0.51. What is the ratio of the Claims (% of GDP) of Heavily indebted poor countries in 2007 to that in 2011?
Offer a very short reply. 0.65. What is the ratio of the Claims (% of GDP) of Nepal in 2007 to that in 2011?
Your answer should be very brief. 0.94. What is the ratio of the Claims (% of GDP) in Uruguay in 2007 to that in 2011?
Provide a short and direct response. 0.01. What is the ratio of the Claims (% of GDP) in Central Europe in 2007 to that in 2012?
Your answer should be compact. 0.54. What is the ratio of the Claims (% of GDP) of Heavily indebted poor countries in 2007 to that in 2012?
Offer a terse response. 0.63. What is the ratio of the Claims (% of GDP) of Nepal in 2007 to that in 2012?
Your answer should be compact. 1.12. What is the ratio of the Claims (% of GDP) of Uruguay in 2007 to that in 2012?
Your response must be concise. 0.01. What is the ratio of the Claims (% of GDP) in Central Europe in 2007 to that in 2013?
Your response must be concise. 0.45. What is the ratio of the Claims (% of GDP) in Heavily indebted poor countries in 2007 to that in 2013?
Ensure brevity in your answer.  0.61. What is the ratio of the Claims (% of GDP) in Nepal in 2007 to that in 2013?
Keep it short and to the point. 1.23. What is the ratio of the Claims (% of GDP) of Uruguay in 2007 to that in 2013?
Your response must be concise. 0.01. What is the ratio of the Claims (% of GDP) in Central Europe in 2008 to that in 2009?
Provide a short and direct response. 0.83. What is the ratio of the Claims (% of GDP) in Heavily indebted poor countries in 2008 to that in 2009?
Keep it short and to the point. 0.67. What is the ratio of the Claims (% of GDP) of Nepal in 2008 to that in 2009?
Offer a terse response. 1.36. What is the ratio of the Claims (% of GDP) in Uruguay in 2008 to that in 2009?
Your response must be concise. 0.9. What is the ratio of the Claims (% of GDP) of Central Europe in 2008 to that in 2010?
Your answer should be compact. 0.71. What is the ratio of the Claims (% of GDP) in Heavily indebted poor countries in 2008 to that in 2010?
Offer a very short reply. 0.62. What is the ratio of the Claims (% of GDP) in Nepal in 2008 to that in 2010?
Your response must be concise. 1.03. What is the ratio of the Claims (% of GDP) of Uruguay in 2008 to that in 2010?
Offer a very short reply. 0.66. What is the ratio of the Claims (% of GDP) in Central Europe in 2008 to that in 2011?
Offer a terse response. 0.71. What is the ratio of the Claims (% of GDP) of Heavily indebted poor countries in 2008 to that in 2011?
Your response must be concise. 0.51. What is the ratio of the Claims (% of GDP) in Nepal in 2008 to that in 2011?
Provide a succinct answer. 0.95. What is the ratio of the Claims (% of GDP) of Uruguay in 2008 to that in 2011?
Offer a very short reply. 1.05. What is the ratio of the Claims (% of GDP) of Central Europe in 2008 to that in 2012?
Your response must be concise. 0.75. What is the ratio of the Claims (% of GDP) of Heavily indebted poor countries in 2008 to that in 2012?
Provide a short and direct response. 0.5. What is the ratio of the Claims (% of GDP) in Nepal in 2008 to that in 2012?
Make the answer very short. 1.14. What is the ratio of the Claims (% of GDP) in Uruguay in 2008 to that in 2012?
Offer a very short reply. 0.82. What is the ratio of the Claims (% of GDP) in Central Europe in 2008 to that in 2013?
Your response must be concise. 0.62. What is the ratio of the Claims (% of GDP) of Heavily indebted poor countries in 2008 to that in 2013?
Make the answer very short. 0.48. What is the ratio of the Claims (% of GDP) in Nepal in 2008 to that in 2013?
Provide a succinct answer. 1.24. What is the ratio of the Claims (% of GDP) of Uruguay in 2008 to that in 2013?
Offer a terse response. 0.67. What is the ratio of the Claims (% of GDP) in Central Europe in 2009 to that in 2010?
Keep it short and to the point. 0.85. What is the ratio of the Claims (% of GDP) in Heavily indebted poor countries in 2009 to that in 2010?
Offer a very short reply. 0.92. What is the ratio of the Claims (% of GDP) in Nepal in 2009 to that in 2010?
Give a very brief answer. 0.76. What is the ratio of the Claims (% of GDP) of Uruguay in 2009 to that in 2010?
Provide a succinct answer. 0.73. What is the ratio of the Claims (% of GDP) of Central Europe in 2009 to that in 2011?
Your answer should be compact. 0.85. What is the ratio of the Claims (% of GDP) of Heavily indebted poor countries in 2009 to that in 2011?
Your response must be concise. 0.76. What is the ratio of the Claims (% of GDP) of Nepal in 2009 to that in 2011?
Your answer should be compact. 0.7. What is the ratio of the Claims (% of GDP) in Uruguay in 2009 to that in 2011?
Provide a short and direct response. 1.16. What is the ratio of the Claims (% of GDP) in Central Europe in 2009 to that in 2012?
Offer a very short reply. 0.9. What is the ratio of the Claims (% of GDP) of Heavily indebted poor countries in 2009 to that in 2012?
Offer a terse response. 0.74. What is the ratio of the Claims (% of GDP) of Nepal in 2009 to that in 2012?
Provide a succinct answer. 0.84. What is the ratio of the Claims (% of GDP) in Uruguay in 2009 to that in 2012?
Your response must be concise. 0.91. What is the ratio of the Claims (% of GDP) of Central Europe in 2009 to that in 2013?
Provide a succinct answer. 0.74. What is the ratio of the Claims (% of GDP) of Heavily indebted poor countries in 2009 to that in 2013?
Your answer should be very brief. 0.72. What is the ratio of the Claims (% of GDP) of Nepal in 2009 to that in 2013?
Offer a very short reply. 0.92. What is the ratio of the Claims (% of GDP) in Uruguay in 2009 to that in 2013?
Make the answer very short. 0.74. What is the ratio of the Claims (% of GDP) in Central Europe in 2010 to that in 2011?
Make the answer very short. 1.01. What is the ratio of the Claims (% of GDP) of Heavily indebted poor countries in 2010 to that in 2011?
Offer a very short reply. 0.83. What is the ratio of the Claims (% of GDP) of Nepal in 2010 to that in 2011?
Your response must be concise. 0.92. What is the ratio of the Claims (% of GDP) of Uruguay in 2010 to that in 2011?
Keep it short and to the point. 1.58. What is the ratio of the Claims (% of GDP) in Central Europe in 2010 to that in 2012?
Provide a short and direct response. 1.06. What is the ratio of the Claims (% of GDP) in Heavily indebted poor countries in 2010 to that in 2012?
Your response must be concise. 0.8. What is the ratio of the Claims (% of GDP) in Nepal in 2010 to that in 2012?
Offer a very short reply. 1.11. What is the ratio of the Claims (% of GDP) of Uruguay in 2010 to that in 2012?
Offer a terse response. 1.23. What is the ratio of the Claims (% of GDP) of Central Europe in 2010 to that in 2013?
Offer a very short reply. 0.87. What is the ratio of the Claims (% of GDP) of Heavily indebted poor countries in 2010 to that in 2013?
Offer a very short reply. 0.79. What is the ratio of the Claims (% of GDP) in Nepal in 2010 to that in 2013?
Offer a very short reply. 1.21. What is the ratio of the Claims (% of GDP) in Uruguay in 2010 to that in 2013?
Offer a very short reply. 1.02. What is the ratio of the Claims (% of GDP) of Central Europe in 2011 to that in 2012?
Offer a terse response. 1.06. What is the ratio of the Claims (% of GDP) of Heavily indebted poor countries in 2011 to that in 2012?
Provide a succinct answer. 0.97. What is the ratio of the Claims (% of GDP) of Nepal in 2011 to that in 2012?
Make the answer very short. 1.2. What is the ratio of the Claims (% of GDP) in Uruguay in 2011 to that in 2012?
Offer a terse response. 0.78. What is the ratio of the Claims (% of GDP) in Central Europe in 2011 to that in 2013?
Keep it short and to the point. 0.87. What is the ratio of the Claims (% of GDP) of Heavily indebted poor countries in 2011 to that in 2013?
Your answer should be very brief. 0.94. What is the ratio of the Claims (% of GDP) of Nepal in 2011 to that in 2013?
Your answer should be very brief. 1.31. What is the ratio of the Claims (% of GDP) in Uruguay in 2011 to that in 2013?
Keep it short and to the point. 0.64. What is the ratio of the Claims (% of GDP) in Central Europe in 2012 to that in 2013?
Provide a short and direct response. 0.82. What is the ratio of the Claims (% of GDP) in Heavily indebted poor countries in 2012 to that in 2013?
Provide a short and direct response. 0.98. What is the ratio of the Claims (% of GDP) in Nepal in 2012 to that in 2013?
Provide a succinct answer. 1.09. What is the ratio of the Claims (% of GDP) of Uruguay in 2012 to that in 2013?
Your response must be concise. 0.82. What is the difference between the highest and the second highest Claims (% of GDP) of Central Europe?
Ensure brevity in your answer.  1.15. What is the difference between the highest and the second highest Claims (% of GDP) in Heavily indebted poor countries?
Keep it short and to the point. 0.11. What is the difference between the highest and the second highest Claims (% of GDP) in Nepal?
Provide a succinct answer. 0.61. What is the difference between the highest and the second highest Claims (% of GDP) of Uruguay?
Keep it short and to the point. 0.13. What is the difference between the highest and the lowest Claims (% of GDP) of Central Europe?
Provide a succinct answer. 4.97. What is the difference between the highest and the lowest Claims (% of GDP) of Heavily indebted poor countries?
Ensure brevity in your answer.  2.44. What is the difference between the highest and the lowest Claims (% of GDP) of Nepal?
Your answer should be very brief. 3.65. What is the difference between the highest and the lowest Claims (% of GDP) of Uruguay?
Your answer should be compact. 8.38. 